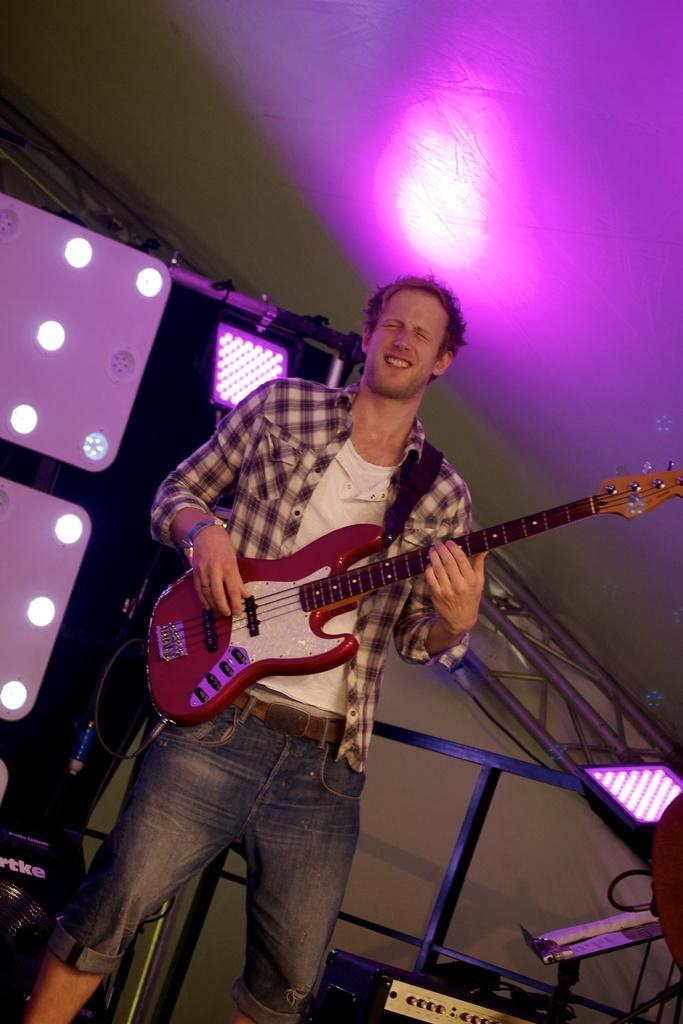Can you describe this image briefly? The man in white T-shirt and check shirt is holding a guitar in his hands and he is playing the guitar. I think he is singing the song. Behind him, we see iron rods and musical equipment. In the background, we see a white wall. At the top, we see the light. This picture might be clicked in the musical concert. 